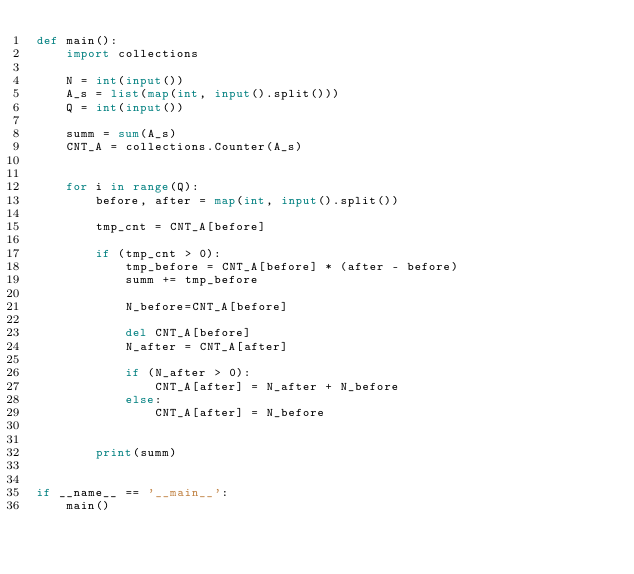Convert code to text. <code><loc_0><loc_0><loc_500><loc_500><_Python_>def main():
    import collections

    N = int(input())
    A_s = list(map(int, input().split()))
    Q = int(input())

    summ = sum(A_s)
    CNT_A = collections.Counter(A_s)


    for i in range(Q):
        before, after = map(int, input().split())
        
        tmp_cnt = CNT_A[before]
        
        if (tmp_cnt > 0):
            tmp_before = CNT_A[before] * (after - before)
            summ += tmp_before

            N_before=CNT_A[before]

            del CNT_A[before]
            N_after = CNT_A[after]
            
            if (N_after > 0):
                CNT_A[after] = N_after + N_before
            else:
                CNT_A[after] = N_before
            
        
        print(summ)


if __name__ == '__main__':
    main()</code> 